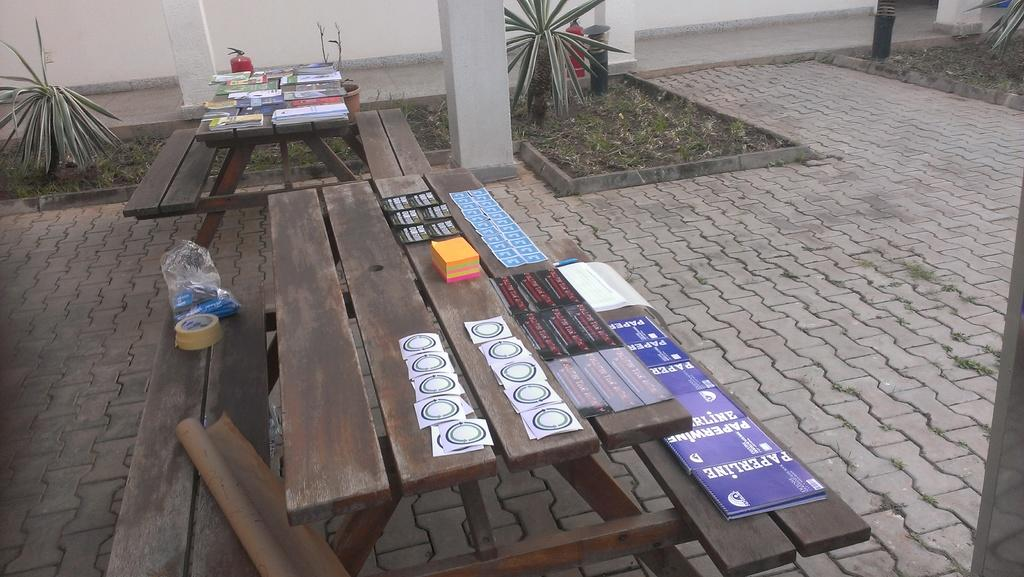What type of furniture can be seen in the image? There are tables in the image. What type of decorations are present in the image? There are posters in the image. What material is visible in the image? There is plaster in the image. What architectural features can be seen in the background of the image? There are pillars in the background of the image. What type of vegetation is visible in the background of the image? There are plants in the background of the image. What is the uncle writing on the table in the image? There is no uncle present in the image, and no writing is visible on the tables. 